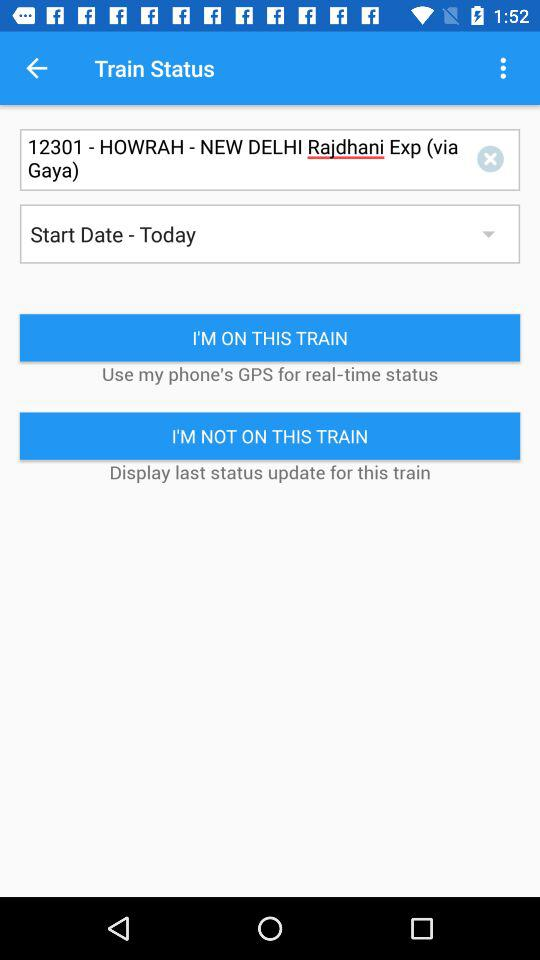What is the train number? The train number is 12301. 